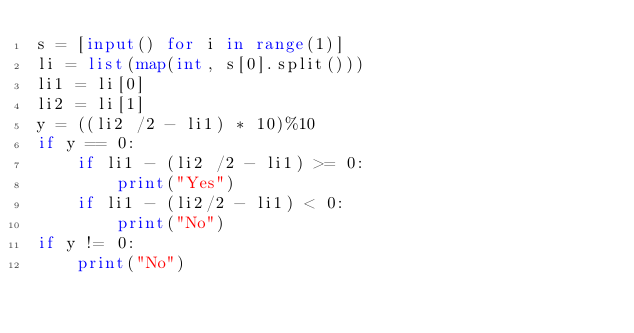<code> <loc_0><loc_0><loc_500><loc_500><_Python_>s = [input() for i in range(1)] 
li = list(map(int, s[0].split()))
li1 = li[0]
li2 = li[1]
y = ((li2 /2 - li1) * 10)%10
if y == 0:
    if li1 - (li2 /2 - li1) >= 0:
        print("Yes")
    if li1 - (li2/2 - li1) < 0:
        print("No")
if y != 0:
    print("No")
    </code> 